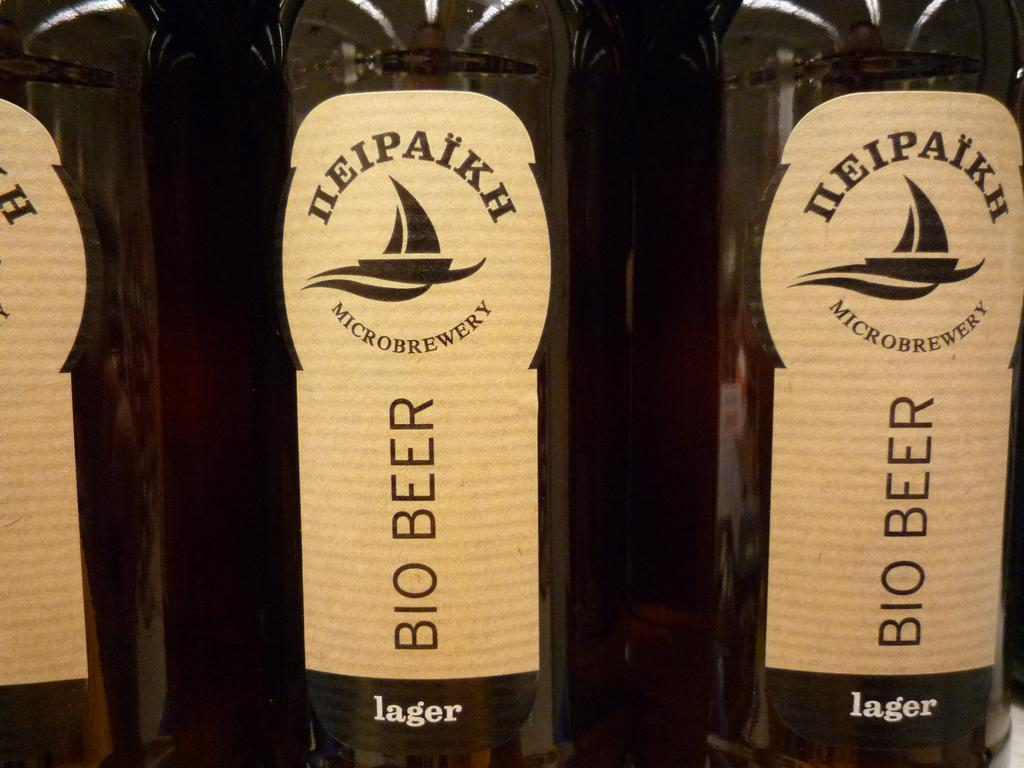How many bottles are visible in the image? There are three bottles in the image. What can be found on each bottle? Each bottle has an image and text on it. How many lizards are sitting on the chin of the person in the image? There is no person or lizards present in the image; it only features three bottles with images and text on them. 